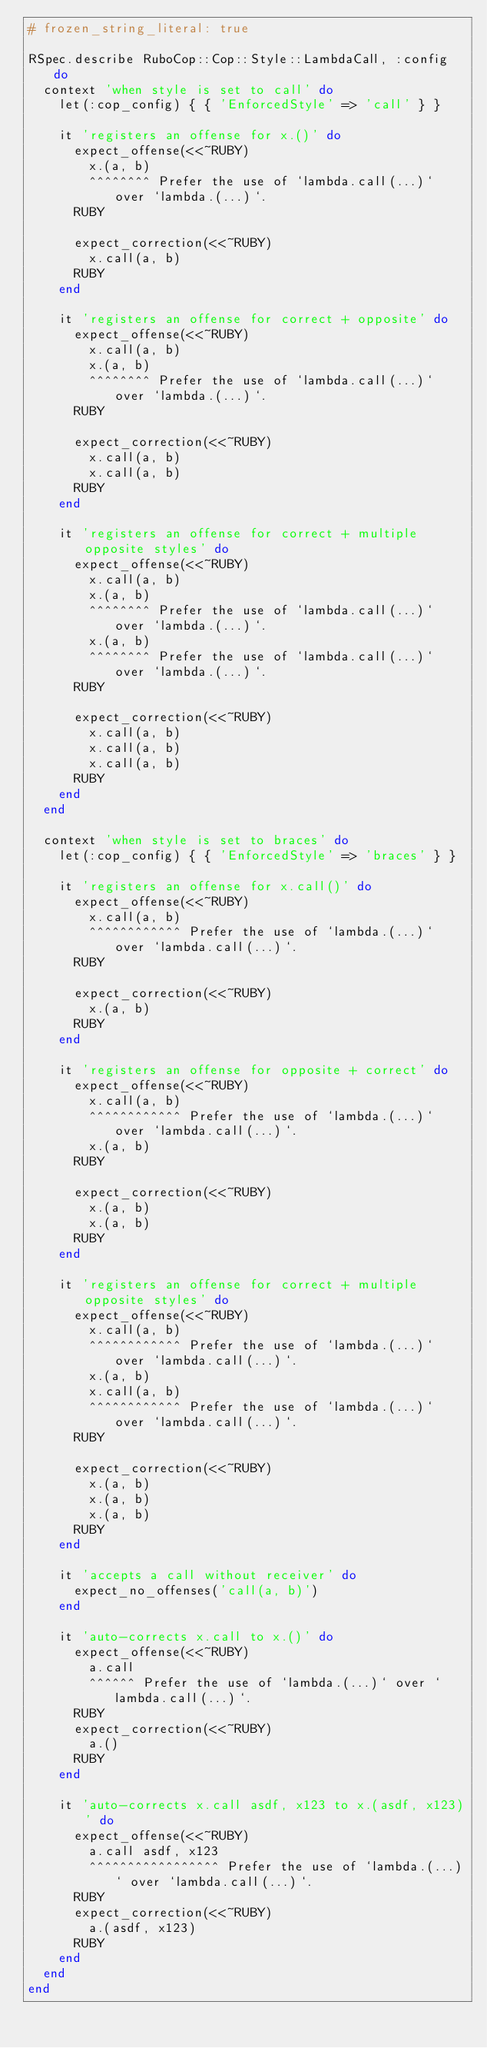Convert code to text. <code><loc_0><loc_0><loc_500><loc_500><_Ruby_># frozen_string_literal: true

RSpec.describe RuboCop::Cop::Style::LambdaCall, :config do
  context 'when style is set to call' do
    let(:cop_config) { { 'EnforcedStyle' => 'call' } }

    it 'registers an offense for x.()' do
      expect_offense(<<~RUBY)
        x.(a, b)
        ^^^^^^^^ Prefer the use of `lambda.call(...)` over `lambda.(...)`.
      RUBY

      expect_correction(<<~RUBY)
        x.call(a, b)
      RUBY
    end

    it 'registers an offense for correct + opposite' do
      expect_offense(<<~RUBY)
        x.call(a, b)
        x.(a, b)
        ^^^^^^^^ Prefer the use of `lambda.call(...)` over `lambda.(...)`.
      RUBY

      expect_correction(<<~RUBY)
        x.call(a, b)
        x.call(a, b)
      RUBY
    end

    it 'registers an offense for correct + multiple opposite styles' do
      expect_offense(<<~RUBY)
        x.call(a, b)
        x.(a, b)
        ^^^^^^^^ Prefer the use of `lambda.call(...)` over `lambda.(...)`.
        x.(a, b)
        ^^^^^^^^ Prefer the use of `lambda.call(...)` over `lambda.(...)`.
      RUBY

      expect_correction(<<~RUBY)
        x.call(a, b)
        x.call(a, b)
        x.call(a, b)
      RUBY
    end
  end

  context 'when style is set to braces' do
    let(:cop_config) { { 'EnforcedStyle' => 'braces' } }

    it 'registers an offense for x.call()' do
      expect_offense(<<~RUBY)
        x.call(a, b)
        ^^^^^^^^^^^^ Prefer the use of `lambda.(...)` over `lambda.call(...)`.
      RUBY

      expect_correction(<<~RUBY)
        x.(a, b)
      RUBY
    end

    it 'registers an offense for opposite + correct' do
      expect_offense(<<~RUBY)
        x.call(a, b)
        ^^^^^^^^^^^^ Prefer the use of `lambda.(...)` over `lambda.call(...)`.
        x.(a, b)
      RUBY

      expect_correction(<<~RUBY)
        x.(a, b)
        x.(a, b)
      RUBY
    end

    it 'registers an offense for correct + multiple opposite styles' do
      expect_offense(<<~RUBY)
        x.call(a, b)
        ^^^^^^^^^^^^ Prefer the use of `lambda.(...)` over `lambda.call(...)`.
        x.(a, b)
        x.call(a, b)
        ^^^^^^^^^^^^ Prefer the use of `lambda.(...)` over `lambda.call(...)`.
      RUBY

      expect_correction(<<~RUBY)
        x.(a, b)
        x.(a, b)
        x.(a, b)
      RUBY
    end

    it 'accepts a call without receiver' do
      expect_no_offenses('call(a, b)')
    end

    it 'auto-corrects x.call to x.()' do
      expect_offense(<<~RUBY)
        a.call
        ^^^^^^ Prefer the use of `lambda.(...)` over `lambda.call(...)`.
      RUBY
      expect_correction(<<~RUBY)
        a.()
      RUBY
    end

    it 'auto-corrects x.call asdf, x123 to x.(asdf, x123)' do
      expect_offense(<<~RUBY)
        a.call asdf, x123
        ^^^^^^^^^^^^^^^^^ Prefer the use of `lambda.(...)` over `lambda.call(...)`.
      RUBY
      expect_correction(<<~RUBY)
        a.(asdf, x123)
      RUBY
    end
  end
end
</code> 